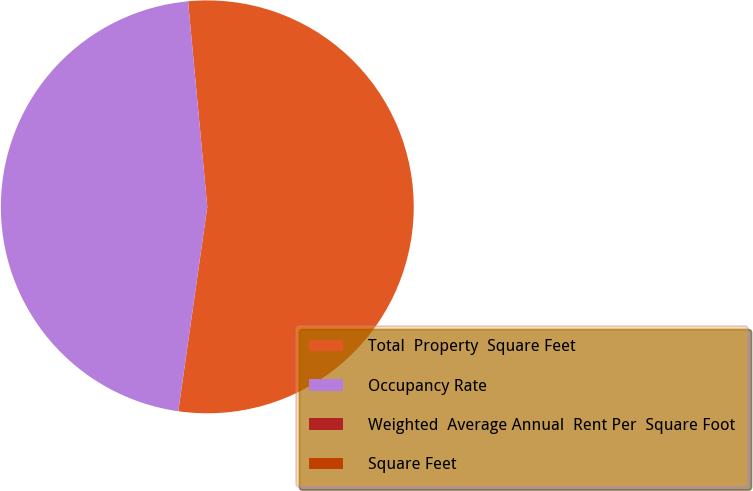Convert chart to OTSL. <chart><loc_0><loc_0><loc_500><loc_500><pie_chart><fcel>Total  Property  Square Feet<fcel>Occupancy Rate<fcel>Weighted  Average Annual  Rent Per  Square Foot<fcel>Square Feet<nl><fcel>53.73%<fcel>46.27%<fcel>0.0%<fcel>0.0%<nl></chart> 